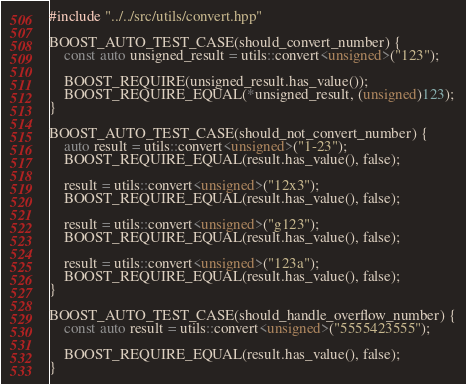Convert code to text. <code><loc_0><loc_0><loc_500><loc_500><_C++_>#include "../../src/utils/convert.hpp"

BOOST_AUTO_TEST_CASE(should_convert_number) {
    const auto unsigned_result = utils::convert<unsigned>("123");

    BOOST_REQUIRE(unsigned_result.has_value());
    BOOST_REQUIRE_EQUAL(*unsigned_result, (unsigned)123);
}

BOOST_AUTO_TEST_CASE(should_not_convert_number) {
    auto result = utils::convert<unsigned>("1-23");
    BOOST_REQUIRE_EQUAL(result.has_value(), false);

    result = utils::convert<unsigned>("12x3");
    BOOST_REQUIRE_EQUAL(result.has_value(), false);

    result = utils::convert<unsigned>("g123");
    BOOST_REQUIRE_EQUAL(result.has_value(), false);

    result = utils::convert<unsigned>("123a");
    BOOST_REQUIRE_EQUAL(result.has_value(), false);
}

BOOST_AUTO_TEST_CASE(should_handle_overflow_number) {
    const auto result = utils::convert<unsigned>("5555423555");

    BOOST_REQUIRE_EQUAL(result.has_value(), false);
}
</code> 